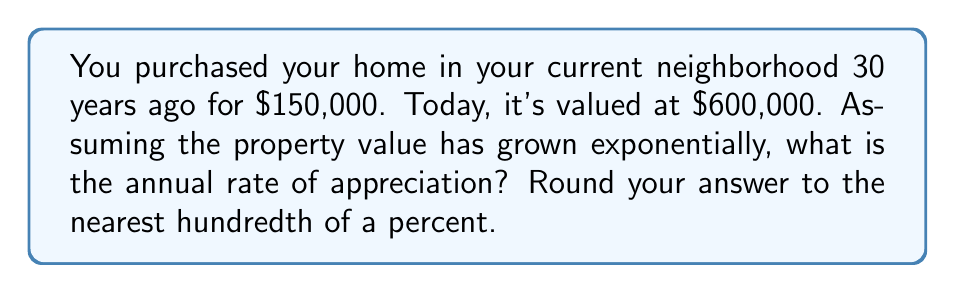Give your solution to this math problem. Let's approach this step-by-step using the exponential growth model:

1) The exponential growth formula is:
   $$A = P(1 + r)^t$$
   where:
   $A$ = final amount
   $P$ = initial principal balance
   $r$ = annual rate (in decimal form)
   $t$ = time in years

2) We know:
   $P = 150,000$
   $A = 600,000$
   $t = 30$

3) Let's substitute these values:
   $$600,000 = 150,000(1 + r)^{30}$$

4) Divide both sides by 150,000:
   $$4 = (1 + r)^{30}$$

5) Take the 30th root of both sides:
   $$\sqrt[30]{4} = 1 + r$$

6) Subtract 1 from both sides:
   $$\sqrt[30]{4} - 1 = r$$

7) Calculate:
   $$r \approx 1.0466 - 1 = 0.0466$$

8) Convert to a percentage and round to the nearest hundredth:
   $$r \approx 4.66\%$$
Answer: 4.66% 